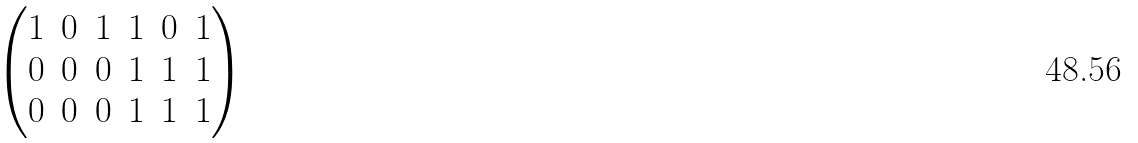Convert formula to latex. <formula><loc_0><loc_0><loc_500><loc_500>\begin{pmatrix} 1 & 0 & 1 & 1 & 0 & 1 \\ 0 & 0 & 0 & 1 & 1 & 1 \\ 0 & 0 & 0 & 1 & 1 & 1 \end{pmatrix}</formula> 